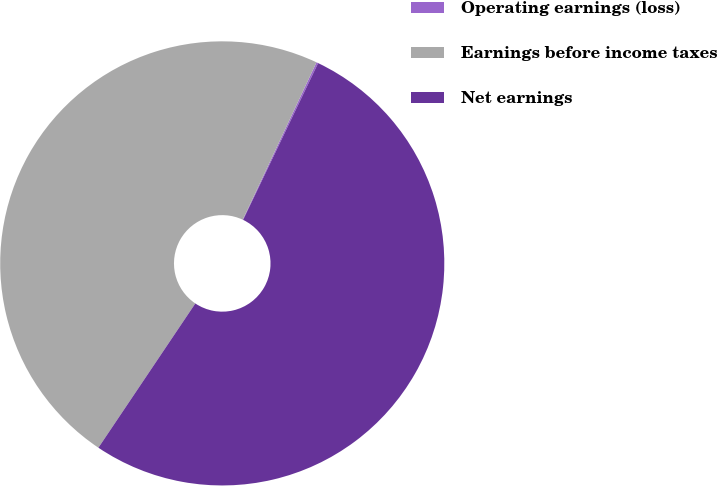Convert chart. <chart><loc_0><loc_0><loc_500><loc_500><pie_chart><fcel>Operating earnings (loss)<fcel>Earnings before income taxes<fcel>Net earnings<nl><fcel>0.13%<fcel>47.56%<fcel>52.31%<nl></chart> 